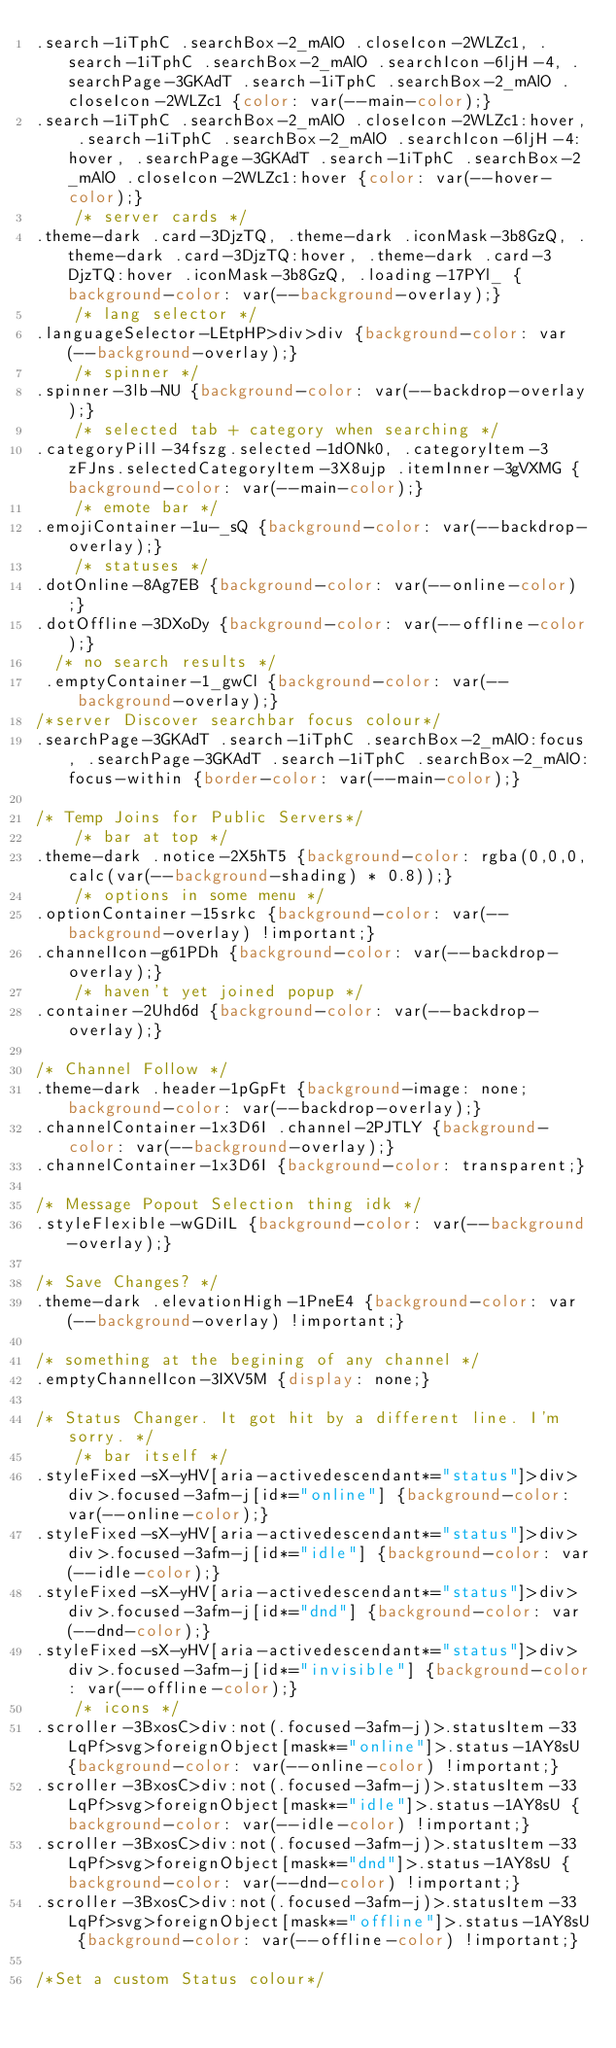Convert code to text. <code><loc_0><loc_0><loc_500><loc_500><_CSS_>.search-1iTphC .searchBox-2_mAlO .closeIcon-2WLZc1, .search-1iTphC .searchBox-2_mAlO .searchIcon-6ljH-4, .searchPage-3GKAdT .search-1iTphC .searchBox-2_mAlO .closeIcon-2WLZc1 {color: var(--main-color);}
.search-1iTphC .searchBox-2_mAlO .closeIcon-2WLZc1:hover, .search-1iTphC .searchBox-2_mAlO .searchIcon-6ljH-4:hover, .searchPage-3GKAdT .search-1iTphC .searchBox-2_mAlO .closeIcon-2WLZc1:hover {color: var(--hover-color);}
    /* server cards */
.theme-dark .card-3DjzTQ, .theme-dark .iconMask-3b8GzQ, .theme-dark .card-3DjzTQ:hover, .theme-dark .card-3DjzTQ:hover .iconMask-3b8GzQ, .loading-17PYl_ {background-color: var(--background-overlay);}
    /* lang selector */
.languageSelector-LEtpHP>div>div {background-color: var(--background-overlay);}
    /* spinner */
.spinner-3lb-NU {background-color: var(--backdrop-overlay);}
    /* selected tab + category when searching */
.categoryPill-34fszg.selected-1dONk0, .categoryItem-3zFJns.selectedCategoryItem-3X8ujp .itemInner-3gVXMG {background-color: var(--main-color);}
    /* emote bar */
.emojiContainer-1u-_sQ {background-color: var(--backdrop-overlay);}
    /* statuses */
.dotOnline-8Ag7EB {background-color: var(--online-color);}
.dotOffline-3DXoDy {background-color: var(--offline-color);}
  /* no search results */
 .emptyContainer-1_gwCl {background-color: var(--background-overlay);}
/*server Discover searchbar focus colour*/
.searchPage-3GKAdT .search-1iTphC .searchBox-2_mAlO:focus, .searchPage-3GKAdT .search-1iTphC .searchBox-2_mAlO:focus-within {border-color: var(--main-color);}

/* Temp Joins for Public Servers*/
    /* bar at top */
.theme-dark .notice-2X5hT5 {background-color: rgba(0,0,0,calc(var(--background-shading) * 0.8));}
    /* options in some menu */
.optionContainer-15srkc {background-color: var(--background-overlay) !important;}
.channelIcon-g61PDh {background-color: var(--backdrop-overlay);}
    /* haven't yet joined popup */
.container-2Uhd6d {background-color: var(--backdrop-overlay);}

/* Channel Follow */
.theme-dark .header-1pGpFt {background-image: none; background-color: var(--backdrop-overlay);}
.channelContainer-1x3D6I .channel-2PJTLY {background-color: var(--background-overlay);}
.channelContainer-1x3D6I {background-color: transparent;}

/* Message Popout Selection thing idk */
.styleFlexible-wGDiIL {background-color: var(--background-overlay);}

/* Save Changes? */
.theme-dark .elevationHigh-1PneE4 {background-color: var(--background-overlay) !important;}

/* something at the begining of any channel */
.emptyChannelIcon-3IXV5M {display: none;}

/* Status Changer. It got hit by a different line. I'm sorry. */
    /* bar itself */
.styleFixed-sX-yHV[aria-activedescendant*="status"]>div>div>.focused-3afm-j[id*="online"] {background-color: var(--online-color);}
.styleFixed-sX-yHV[aria-activedescendant*="status"]>div>div>.focused-3afm-j[id*="idle"] {background-color: var(--idle-color);}
.styleFixed-sX-yHV[aria-activedescendant*="status"]>div>div>.focused-3afm-j[id*="dnd"] {background-color: var(--dnd-color);}
.styleFixed-sX-yHV[aria-activedescendant*="status"]>div>div>.focused-3afm-j[id*="invisible"] {background-color: var(--offline-color);}
    /* icons */
.scroller-3BxosC>div:not(.focused-3afm-j)>.statusItem-33LqPf>svg>foreignObject[mask*="online"]>.status-1AY8sU {background-color: var(--online-color) !important;}
.scroller-3BxosC>div:not(.focused-3afm-j)>.statusItem-33LqPf>svg>foreignObject[mask*="idle"]>.status-1AY8sU {background-color: var(--idle-color) !important;}
.scroller-3BxosC>div:not(.focused-3afm-j)>.statusItem-33LqPf>svg>foreignObject[mask*="dnd"]>.status-1AY8sU {background-color: var(--dnd-color) !important;}
.scroller-3BxosC>div:not(.focused-3afm-j)>.statusItem-33LqPf>svg>foreignObject[mask*="offline"]>.status-1AY8sU {background-color: var(--offline-color) !important;}

/*Set a custom Status colour*/</code> 